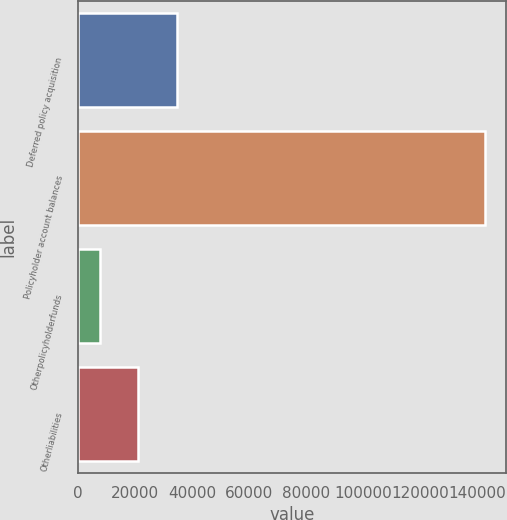Convert chart. <chart><loc_0><loc_0><loc_500><loc_500><bar_chart><fcel>Deferred policy acquisition<fcel>Policyholder account balances<fcel>Otherpolicyholderfunds<fcel>Otherliabilities<nl><fcel>34793.8<fcel>142921<fcel>7762<fcel>21277.9<nl></chart> 